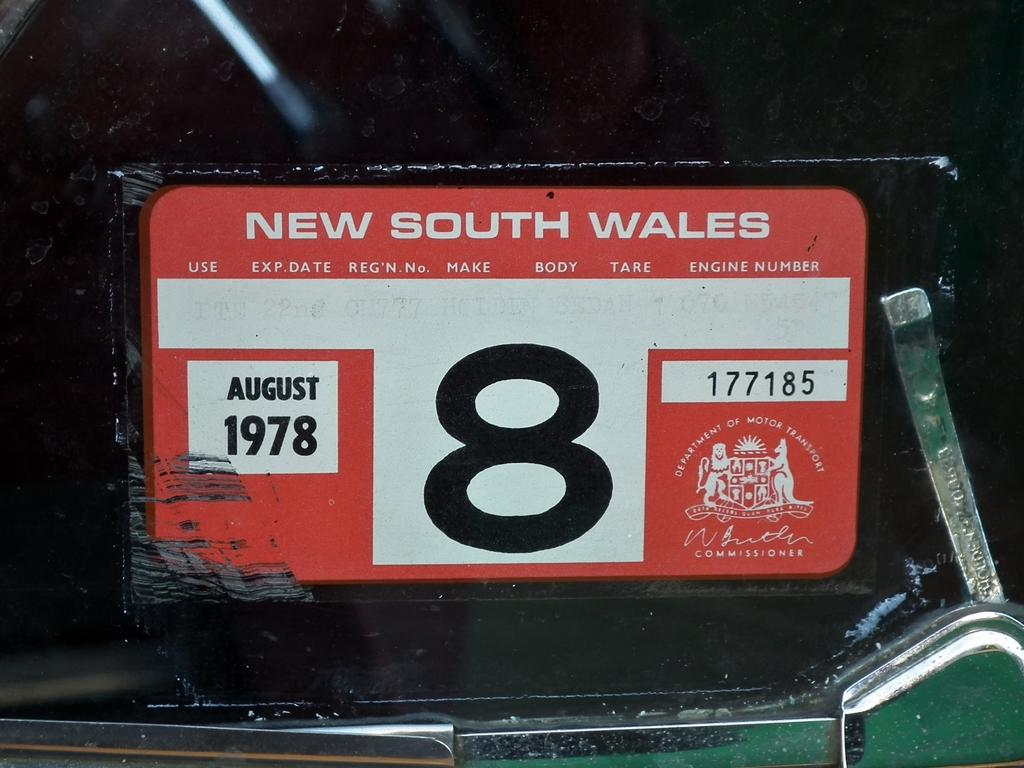<image>
Give a short and clear explanation of the subsequent image. A license plates from New South Wales with the expiration date of August 1978. 